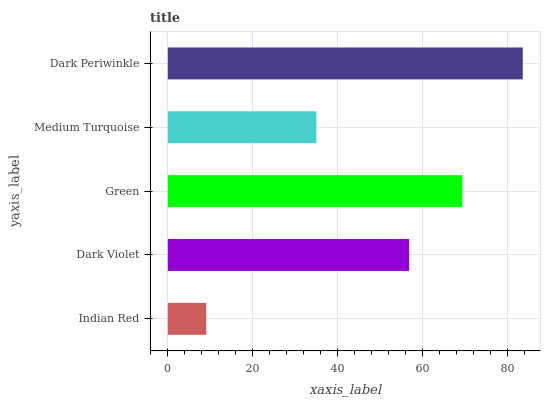Is Indian Red the minimum?
Answer yes or no. Yes. Is Dark Periwinkle the maximum?
Answer yes or no. Yes. Is Dark Violet the minimum?
Answer yes or no. No. Is Dark Violet the maximum?
Answer yes or no. No. Is Dark Violet greater than Indian Red?
Answer yes or no. Yes. Is Indian Red less than Dark Violet?
Answer yes or no. Yes. Is Indian Red greater than Dark Violet?
Answer yes or no. No. Is Dark Violet less than Indian Red?
Answer yes or no. No. Is Dark Violet the high median?
Answer yes or no. Yes. Is Dark Violet the low median?
Answer yes or no. Yes. Is Green the high median?
Answer yes or no. No. Is Dark Periwinkle the low median?
Answer yes or no. No. 